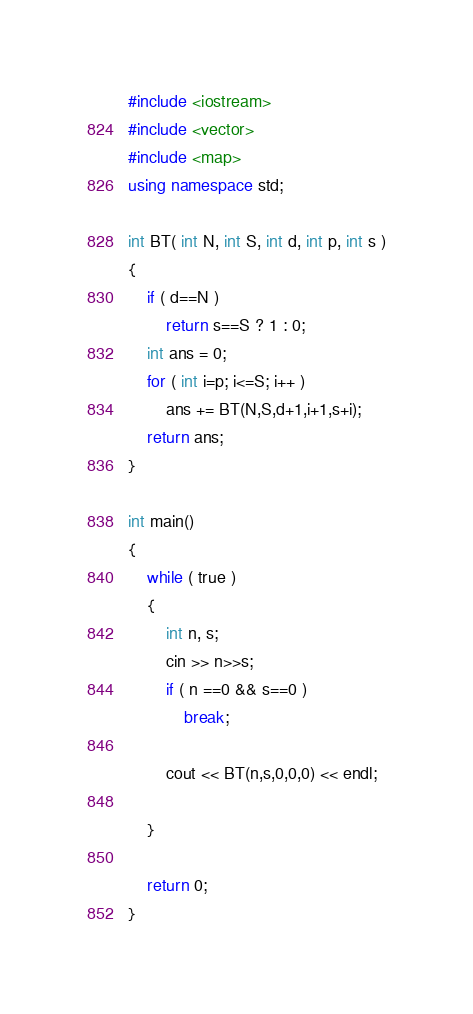<code> <loc_0><loc_0><loc_500><loc_500><_C++_>#include <iostream>
#include <vector>
#include <map>
using namespace std;

int BT( int N, int S, int d, int p, int s )
{
	if ( d==N )
		return s==S ? 1 : 0;
	int ans = 0;
	for ( int i=p; i<=S; i++ )
		ans += BT(N,S,d+1,i+1,s+i);
	return ans;
}

int main()
{
	while ( true )
	{
		int n, s;
		cin >> n>>s;
		if ( n ==0 && s==0 )
			break;

		cout << BT(n,s,0,0,0) << endl;

	}

	return 0;
}</code> 